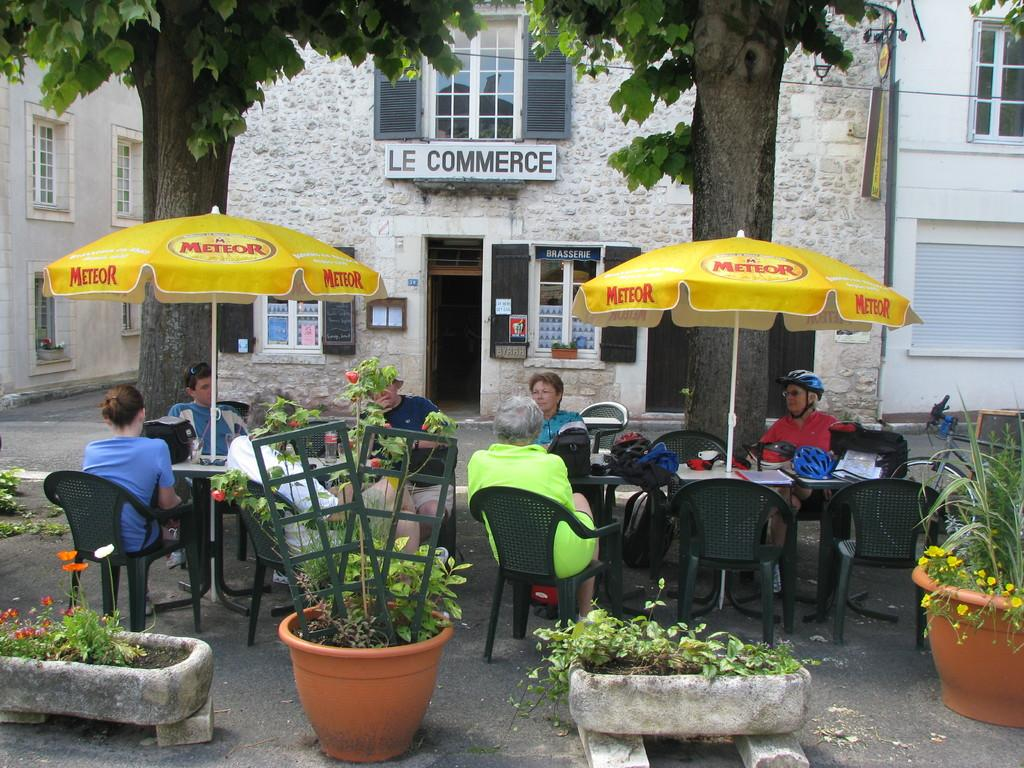What are the people in the image doing? The people in the image are sitting on chairs. What is in front of the people? There is a table in front of the people. What object is on the table? There is a helmet on the table. What can be seen in the background of the image? There is a building visible in the background of the image. What type of pear is being used for writing on the table in the image? There is no pear present in the image, and no writing is taking place on the table. 